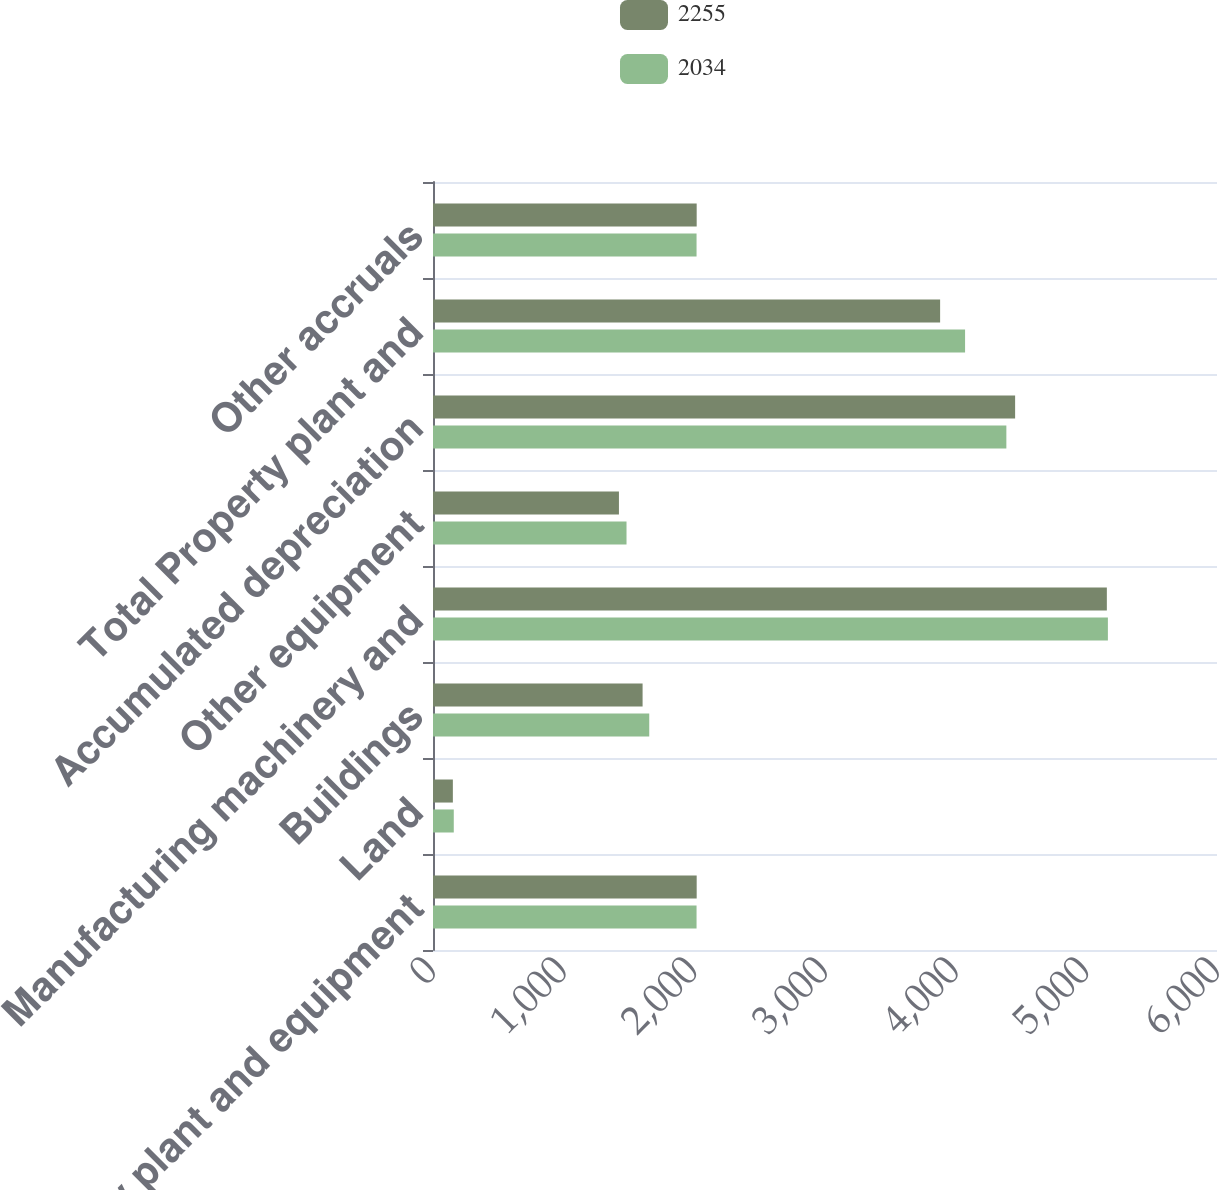Convert chart. <chart><loc_0><loc_0><loc_500><loc_500><stacked_bar_chart><ecel><fcel>Property plant and equipment<fcel>Land<fcel>Buildings<fcel>Manufacturing machinery and<fcel>Other equipment<fcel>Accumulated depreciation<fcel>Total Property plant and<fcel>Other accruals<nl><fcel>2255<fcel>2018<fcel>152<fcel>1604<fcel>5157<fcel>1423<fcel>4455<fcel>3881<fcel>2018<nl><fcel>2034<fcel>2017<fcel>159<fcel>1655<fcel>5165<fcel>1481<fcel>4388<fcel>4072<fcel>2017<nl></chart> 